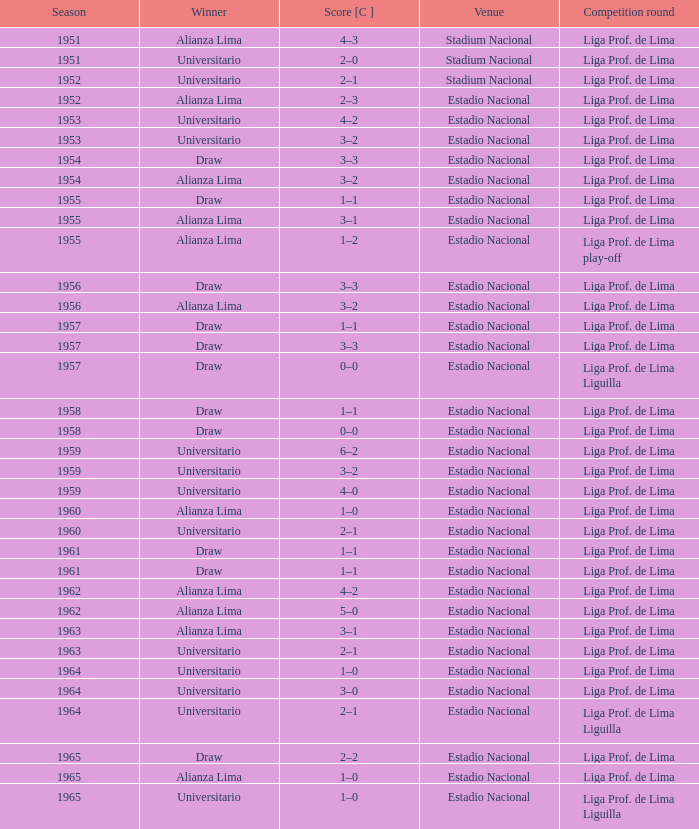What is the most recent season with a date of 27 October 1957? 1957.0. 